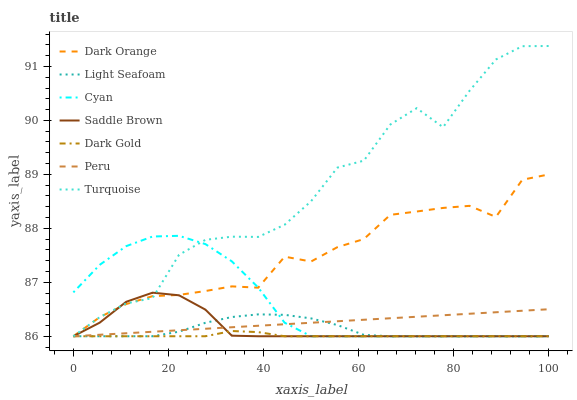Does Dark Gold have the minimum area under the curve?
Answer yes or no. Yes. Does Turquoise have the maximum area under the curve?
Answer yes or no. Yes. Does Turquoise have the minimum area under the curve?
Answer yes or no. No. Does Dark Gold have the maximum area under the curve?
Answer yes or no. No. Is Peru the smoothest?
Answer yes or no. Yes. Is Turquoise the roughest?
Answer yes or no. Yes. Is Dark Gold the smoothest?
Answer yes or no. No. Is Dark Gold the roughest?
Answer yes or no. No. Does Turquoise have the highest value?
Answer yes or no. Yes. Does Dark Gold have the highest value?
Answer yes or no. No. Does Dark Orange intersect Saddle Brown?
Answer yes or no. Yes. Is Dark Orange less than Saddle Brown?
Answer yes or no. No. Is Dark Orange greater than Saddle Brown?
Answer yes or no. No. 